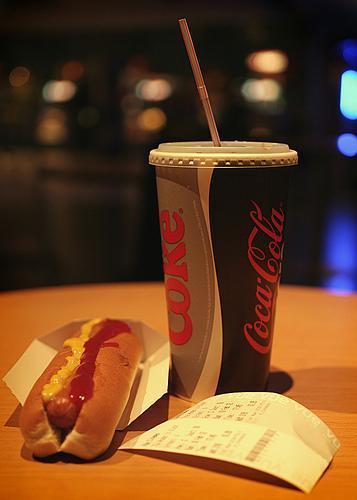How many hot dogs are there?
Give a very brief answer. 1. 